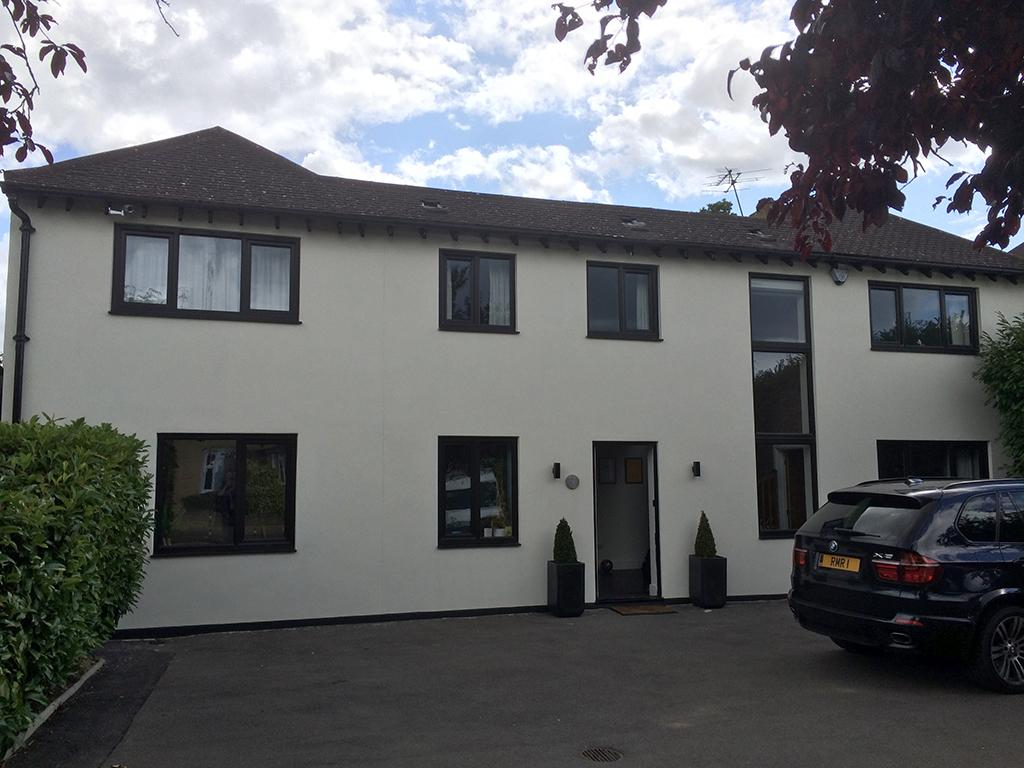What is located on the ground in the image? There is a car on the ground in the image. What type of plants can be seen in the image? There are house plants in the image. What is placed near the entrance of the building? There is a door mat in the image. What decorative elements are present on the walls in the image? There are frames on the wall in the image. What type of window treatment is visible in the image? There are curtains in the image. What type of structure is visible in the image? There is a building with windows in the image. What can be seen in the background of the image? The sky with clouds is visible in the background of the image. What type of prose is being recited by the car in the image? There is no indication in the image that the car is reciting any prose. What is the cause of the loss experienced by the house plants in the image? There is no indication of any loss experienced by the house plants in the image. 